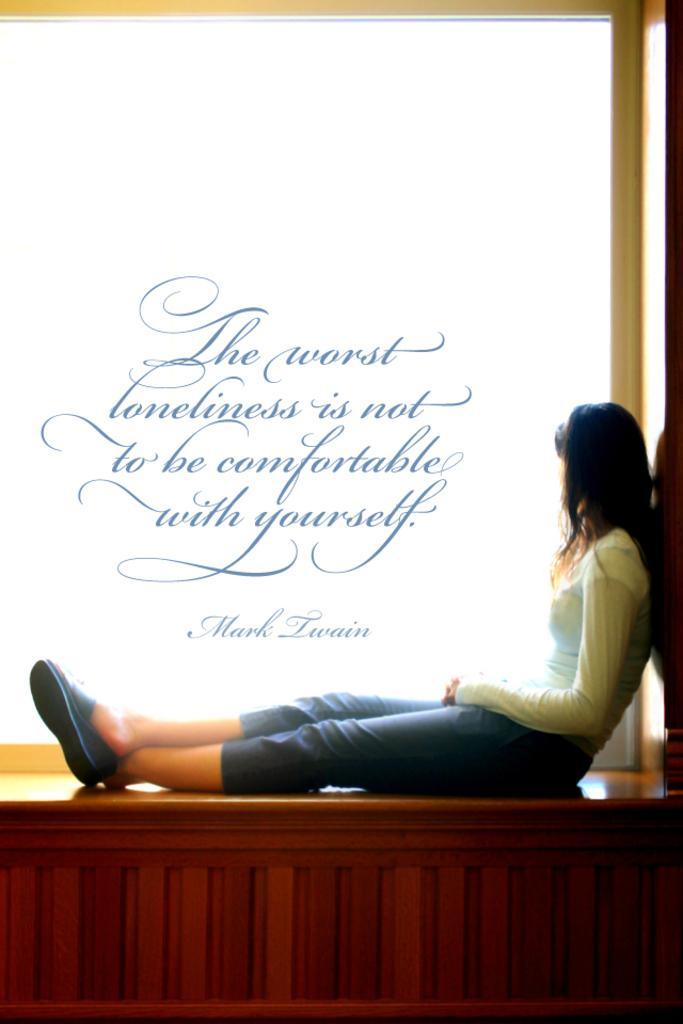How would you summarize this image in a sentence or two? In this image in the front there is a person sitting on the bench and there is some text written on the image. 